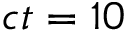<formula> <loc_0><loc_0><loc_500><loc_500>c t = 1 0</formula> 